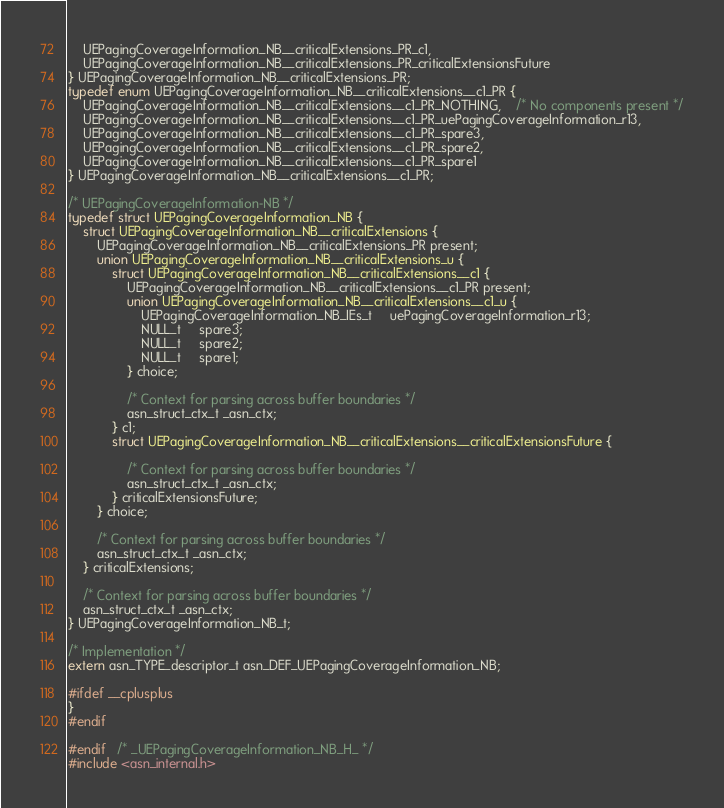Convert code to text. <code><loc_0><loc_0><loc_500><loc_500><_C_>	UEPagingCoverageInformation_NB__criticalExtensions_PR_c1,
	UEPagingCoverageInformation_NB__criticalExtensions_PR_criticalExtensionsFuture
} UEPagingCoverageInformation_NB__criticalExtensions_PR;
typedef enum UEPagingCoverageInformation_NB__criticalExtensions__c1_PR {
	UEPagingCoverageInformation_NB__criticalExtensions__c1_PR_NOTHING,	/* No components present */
	UEPagingCoverageInformation_NB__criticalExtensions__c1_PR_uePagingCoverageInformation_r13,
	UEPagingCoverageInformation_NB__criticalExtensions__c1_PR_spare3,
	UEPagingCoverageInformation_NB__criticalExtensions__c1_PR_spare2,
	UEPagingCoverageInformation_NB__criticalExtensions__c1_PR_spare1
} UEPagingCoverageInformation_NB__criticalExtensions__c1_PR;

/* UEPagingCoverageInformation-NB */
typedef struct UEPagingCoverageInformation_NB {
	struct UEPagingCoverageInformation_NB__criticalExtensions {
		UEPagingCoverageInformation_NB__criticalExtensions_PR present;
		union UEPagingCoverageInformation_NB__criticalExtensions_u {
			struct UEPagingCoverageInformation_NB__criticalExtensions__c1 {
				UEPagingCoverageInformation_NB__criticalExtensions__c1_PR present;
				union UEPagingCoverageInformation_NB__criticalExtensions__c1_u {
					UEPagingCoverageInformation_NB_IEs_t	 uePagingCoverageInformation_r13;
					NULL_t	 spare3;
					NULL_t	 spare2;
					NULL_t	 spare1;
				} choice;
				
				/* Context for parsing across buffer boundaries */
				asn_struct_ctx_t _asn_ctx;
			} c1;
			struct UEPagingCoverageInformation_NB__criticalExtensions__criticalExtensionsFuture {
				
				/* Context for parsing across buffer boundaries */
				asn_struct_ctx_t _asn_ctx;
			} criticalExtensionsFuture;
		} choice;
		
		/* Context for parsing across buffer boundaries */
		asn_struct_ctx_t _asn_ctx;
	} criticalExtensions;
	
	/* Context for parsing across buffer boundaries */
	asn_struct_ctx_t _asn_ctx;
} UEPagingCoverageInformation_NB_t;

/* Implementation */
extern asn_TYPE_descriptor_t asn_DEF_UEPagingCoverageInformation_NB;

#ifdef __cplusplus
}
#endif

#endif	/* _UEPagingCoverageInformation_NB_H_ */
#include <asn_internal.h>
</code> 